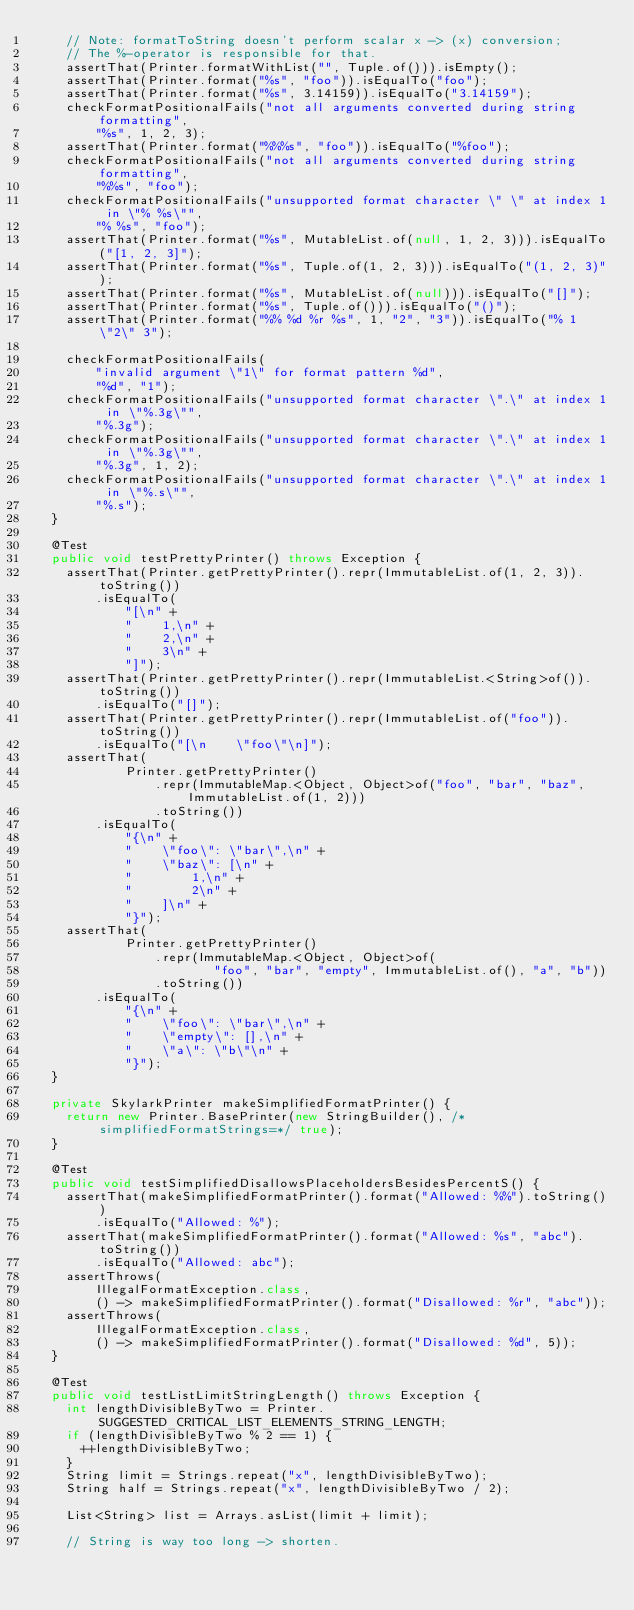Convert code to text. <code><loc_0><loc_0><loc_500><loc_500><_Java_>    // Note: formatToString doesn't perform scalar x -> (x) conversion;
    // The %-operator is responsible for that.
    assertThat(Printer.formatWithList("", Tuple.of())).isEmpty();
    assertThat(Printer.format("%s", "foo")).isEqualTo("foo");
    assertThat(Printer.format("%s", 3.14159)).isEqualTo("3.14159");
    checkFormatPositionalFails("not all arguments converted during string formatting",
        "%s", 1, 2, 3);
    assertThat(Printer.format("%%%s", "foo")).isEqualTo("%foo");
    checkFormatPositionalFails("not all arguments converted during string formatting",
        "%%s", "foo");
    checkFormatPositionalFails("unsupported format character \" \" at index 1 in \"% %s\"",
        "% %s", "foo");
    assertThat(Printer.format("%s", MutableList.of(null, 1, 2, 3))).isEqualTo("[1, 2, 3]");
    assertThat(Printer.format("%s", Tuple.of(1, 2, 3))).isEqualTo("(1, 2, 3)");
    assertThat(Printer.format("%s", MutableList.of(null))).isEqualTo("[]");
    assertThat(Printer.format("%s", Tuple.of())).isEqualTo("()");
    assertThat(Printer.format("%% %d %r %s", 1, "2", "3")).isEqualTo("% 1 \"2\" 3");

    checkFormatPositionalFails(
        "invalid argument \"1\" for format pattern %d",
        "%d", "1");
    checkFormatPositionalFails("unsupported format character \".\" at index 1 in \"%.3g\"",
        "%.3g");
    checkFormatPositionalFails("unsupported format character \".\" at index 1 in \"%.3g\"",
        "%.3g", 1, 2);
    checkFormatPositionalFails("unsupported format character \".\" at index 1 in \"%.s\"",
        "%.s");
  }

  @Test
  public void testPrettyPrinter() throws Exception {
    assertThat(Printer.getPrettyPrinter().repr(ImmutableList.of(1, 2, 3)).toString())
        .isEqualTo(
            "[\n" +
            "    1,\n" +
            "    2,\n" +
            "    3\n" +
            "]");
    assertThat(Printer.getPrettyPrinter().repr(ImmutableList.<String>of()).toString())
        .isEqualTo("[]");
    assertThat(Printer.getPrettyPrinter().repr(ImmutableList.of("foo")).toString())
        .isEqualTo("[\n    \"foo\"\n]");
    assertThat(
            Printer.getPrettyPrinter()
                .repr(ImmutableMap.<Object, Object>of("foo", "bar", "baz", ImmutableList.of(1, 2)))
                .toString())
        .isEqualTo(
            "{\n" +
            "    \"foo\": \"bar\",\n" +
            "    \"baz\": [\n" +
            "        1,\n" +
            "        2\n" +
            "    ]\n" +
            "}");
    assertThat(
            Printer.getPrettyPrinter()
                .repr(ImmutableMap.<Object, Object>of(
                        "foo", "bar", "empty", ImmutableList.of(), "a", "b"))
                .toString())
        .isEqualTo(
            "{\n" +
            "    \"foo\": \"bar\",\n" +
            "    \"empty\": [],\n" +
            "    \"a\": \"b\"\n" +
            "}");
  }

  private SkylarkPrinter makeSimplifiedFormatPrinter() {
    return new Printer.BasePrinter(new StringBuilder(), /*simplifiedFormatStrings=*/ true);
  }

  @Test
  public void testSimplifiedDisallowsPlaceholdersBesidesPercentS() {
    assertThat(makeSimplifiedFormatPrinter().format("Allowed: %%").toString())
        .isEqualTo("Allowed: %");
    assertThat(makeSimplifiedFormatPrinter().format("Allowed: %s", "abc").toString())
        .isEqualTo("Allowed: abc");
    assertThrows(
        IllegalFormatException.class,
        () -> makeSimplifiedFormatPrinter().format("Disallowed: %r", "abc"));
    assertThrows(
        IllegalFormatException.class,
        () -> makeSimplifiedFormatPrinter().format("Disallowed: %d", 5));
  }

  @Test
  public void testListLimitStringLength() throws Exception {
    int lengthDivisibleByTwo = Printer.SUGGESTED_CRITICAL_LIST_ELEMENTS_STRING_LENGTH;
    if (lengthDivisibleByTwo % 2 == 1) {
      ++lengthDivisibleByTwo;
    }
    String limit = Strings.repeat("x", lengthDivisibleByTwo);
    String half = Strings.repeat("x", lengthDivisibleByTwo / 2);

    List<String> list = Arrays.asList(limit + limit);

    // String is way too long -> shorten.</code> 